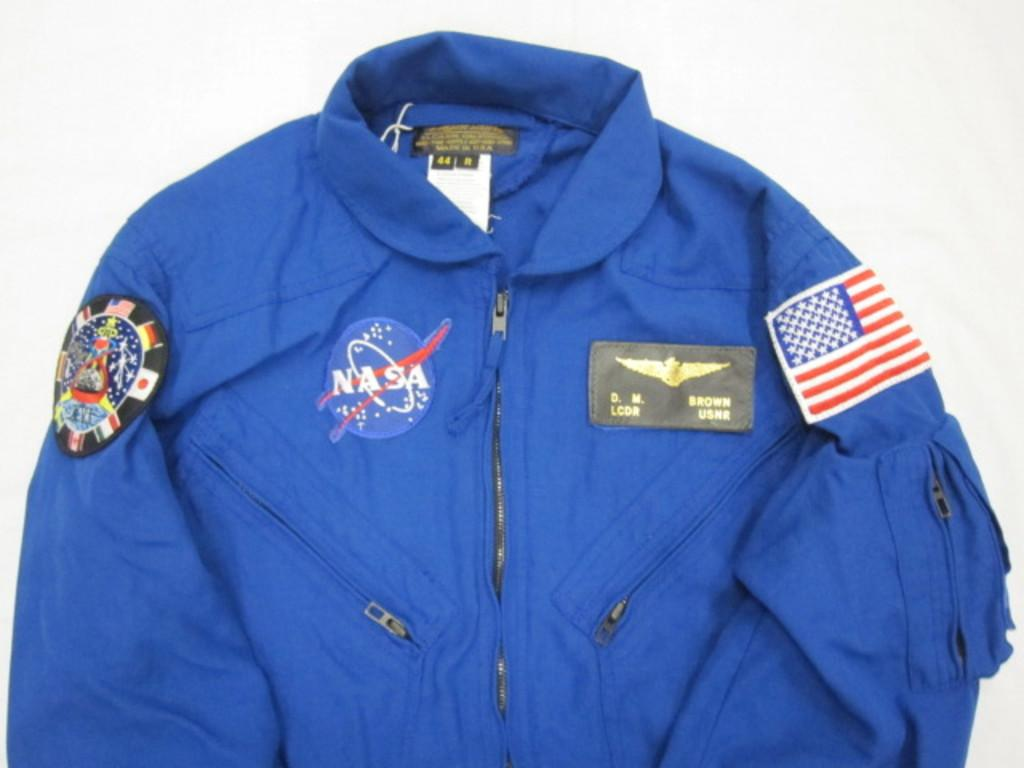<image>
Describe the image concisely. blue nasa flight suit that belongs to d.m. brown 